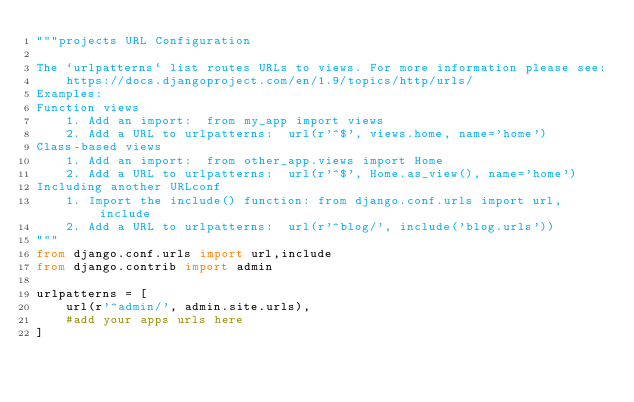<code> <loc_0><loc_0><loc_500><loc_500><_Python_>"""projects URL Configuration

The `urlpatterns` list routes URLs to views. For more information please see:
    https://docs.djangoproject.com/en/1.9/topics/http/urls/
Examples:
Function views
    1. Add an import:  from my_app import views
    2. Add a URL to urlpatterns:  url(r'^$', views.home, name='home')
Class-based views
    1. Add an import:  from other_app.views import Home
    2. Add a URL to urlpatterns:  url(r'^$', Home.as_view(), name='home')
Including another URLconf
    1. Import the include() function: from django.conf.urls import url, include
    2. Add a URL to urlpatterns:  url(r'^blog/', include('blog.urls'))
"""
from django.conf.urls import url,include
from django.contrib import admin

urlpatterns = [
    url(r'^admin/', admin.site.urls),
    #add your apps urls here
]
</code> 